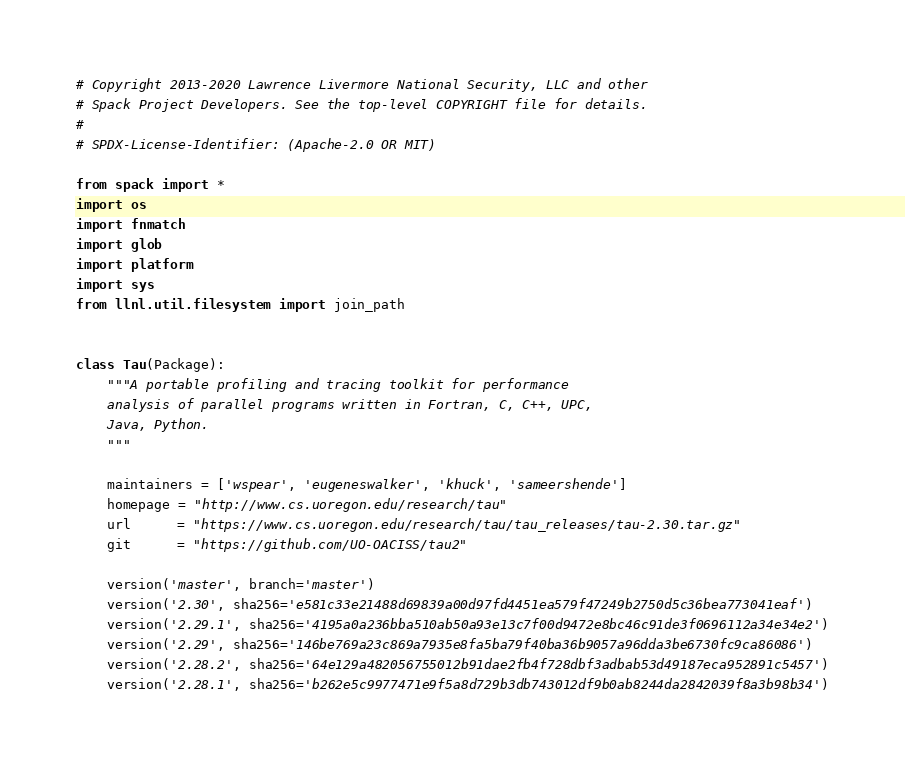<code> <loc_0><loc_0><loc_500><loc_500><_Python_># Copyright 2013-2020 Lawrence Livermore National Security, LLC and other
# Spack Project Developers. See the top-level COPYRIGHT file for details.
#
# SPDX-License-Identifier: (Apache-2.0 OR MIT)

from spack import *
import os
import fnmatch
import glob
import platform
import sys
from llnl.util.filesystem import join_path


class Tau(Package):
    """A portable profiling and tracing toolkit for performance
    analysis of parallel programs written in Fortran, C, C++, UPC,
    Java, Python.
    """

    maintainers = ['wspear', 'eugeneswalker', 'khuck', 'sameershende']
    homepage = "http://www.cs.uoregon.edu/research/tau"
    url      = "https://www.cs.uoregon.edu/research/tau/tau_releases/tau-2.30.tar.gz"
    git      = "https://github.com/UO-OACISS/tau2"

    version('master', branch='master')
    version('2.30', sha256='e581c33e21488d69839a00d97fd4451ea579f47249b2750d5c36bea773041eaf')
    version('2.29.1', sha256='4195a0a236bba510ab50a93e13c7f00d9472e8bc46c91de3f0696112a34e34e2')
    version('2.29', sha256='146be769a23c869a7935e8fa5ba79f40ba36b9057a96dda3be6730fc9ca86086')
    version('2.28.2', sha256='64e129a482056755012b91dae2fb4f728dbf3adbab53d49187eca952891c5457')
    version('2.28.1', sha256='b262e5c9977471e9f5a8d729b3db743012df9b0ab8244da2842039f8a3b98b34')</code> 